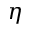Convert formula to latex. <formula><loc_0><loc_0><loc_500><loc_500>\eta</formula> 